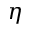Convert formula to latex. <formula><loc_0><loc_0><loc_500><loc_500>\eta</formula> 